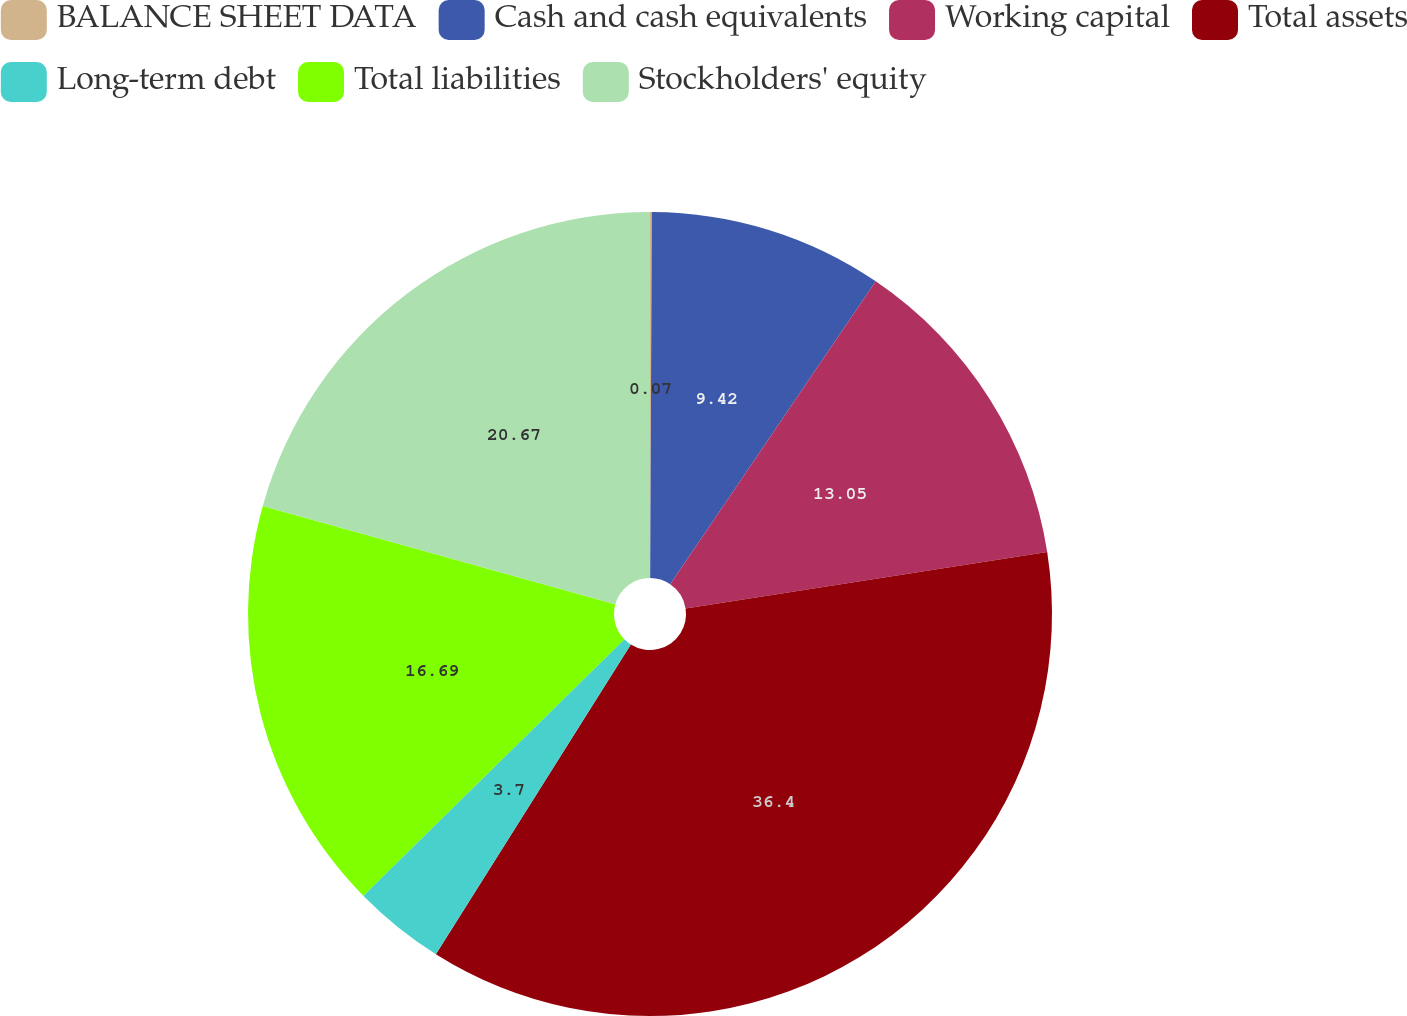Convert chart to OTSL. <chart><loc_0><loc_0><loc_500><loc_500><pie_chart><fcel>BALANCE SHEET DATA<fcel>Cash and cash equivalents<fcel>Working capital<fcel>Total assets<fcel>Long-term debt<fcel>Total liabilities<fcel>Stockholders' equity<nl><fcel>0.07%<fcel>9.42%<fcel>13.05%<fcel>36.4%<fcel>3.7%<fcel>16.69%<fcel>20.67%<nl></chart> 